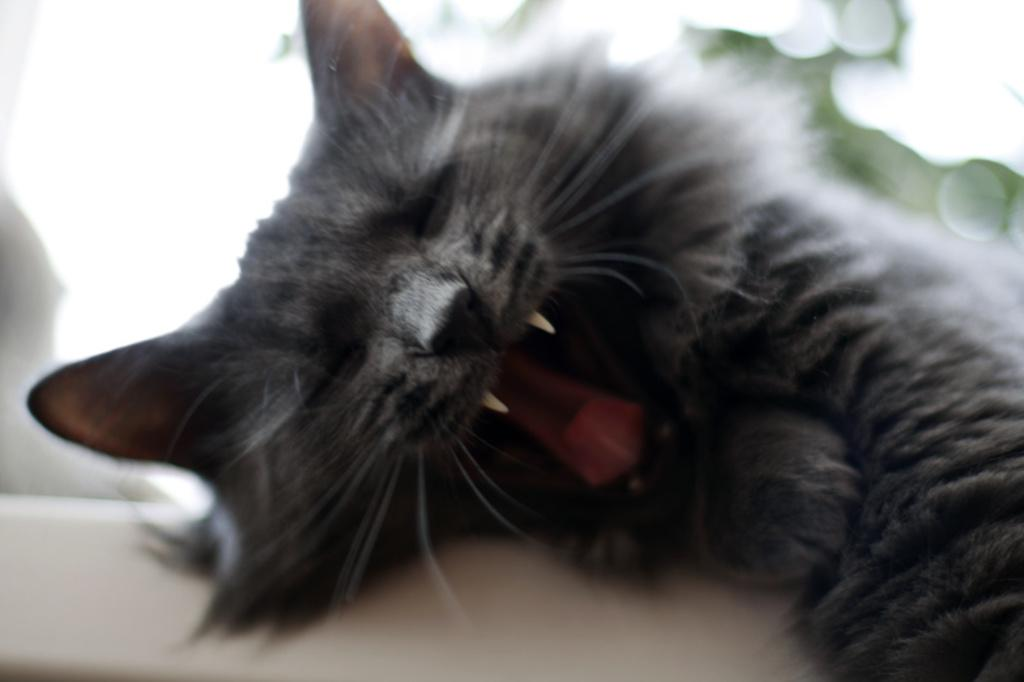What type of animal is in the image? There is a cat in the image. What is the cat doing in the image? The cat is laying down and opening its mouth. What colors can be seen on the cat's fur? The cat has a black and gray color. What is a characteristic feature of the cat's body? The cat has fur. Where is the cat going on vacation in the image? There is no indication of a vacation in the image; it simply shows a cat laying down and opening its mouth. What type of sport is the cat playing in the image? There is no sport or basketball present in the image; it only features a cat laying down and opening its mouth. 